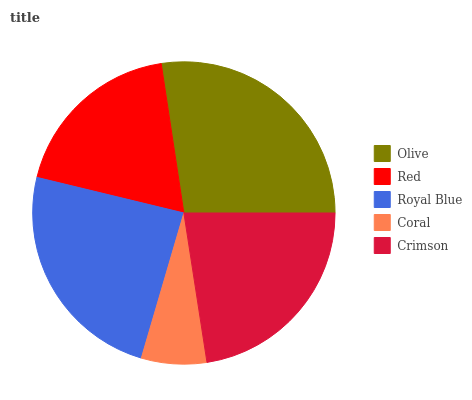Is Coral the minimum?
Answer yes or no. Yes. Is Olive the maximum?
Answer yes or no. Yes. Is Red the minimum?
Answer yes or no. No. Is Red the maximum?
Answer yes or no. No. Is Olive greater than Red?
Answer yes or no. Yes. Is Red less than Olive?
Answer yes or no. Yes. Is Red greater than Olive?
Answer yes or no. No. Is Olive less than Red?
Answer yes or no. No. Is Crimson the high median?
Answer yes or no. Yes. Is Crimson the low median?
Answer yes or no. Yes. Is Red the high median?
Answer yes or no. No. Is Olive the low median?
Answer yes or no. No. 